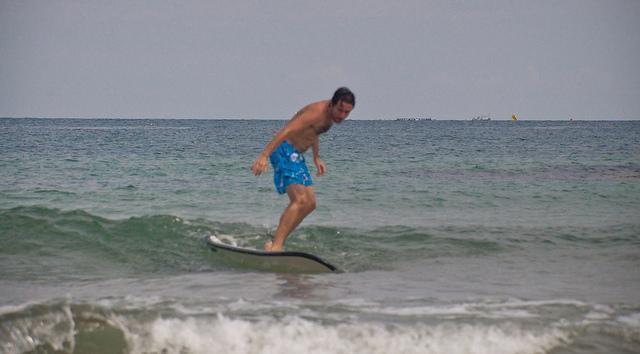How many people are in the scene?
Give a very brief answer. 1. How many chairs are in the picture?
Give a very brief answer. 0. 